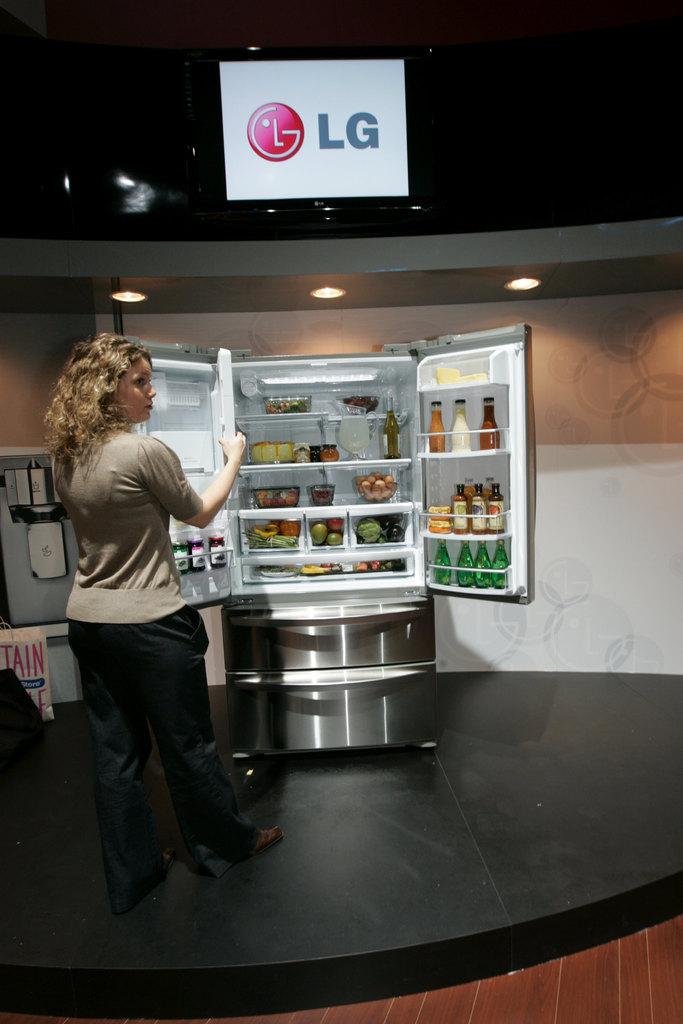What brand is the refrigerator?
Provide a short and direct response. Lg. What are the letters in red on the white shopping bag?
Provide a short and direct response. Tain. 